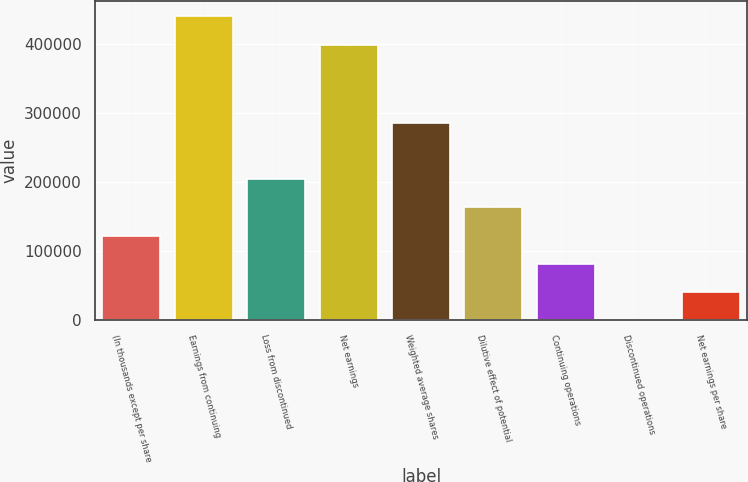Convert chart to OTSL. <chart><loc_0><loc_0><loc_500><loc_500><bar_chart><fcel>(In thousands except per share<fcel>Earnings from continuing<fcel>Loss from discontinued<fcel>Net earnings<fcel>Weighted average shares<fcel>Dilutive effect of potential<fcel>Continuing operations<fcel>Discontinued operations<fcel>Net earnings per share<nl><fcel>122588<fcel>439796<fcel>204313<fcel>398933<fcel>286038<fcel>163450<fcel>81725.3<fcel>0.08<fcel>40862.7<nl></chart> 